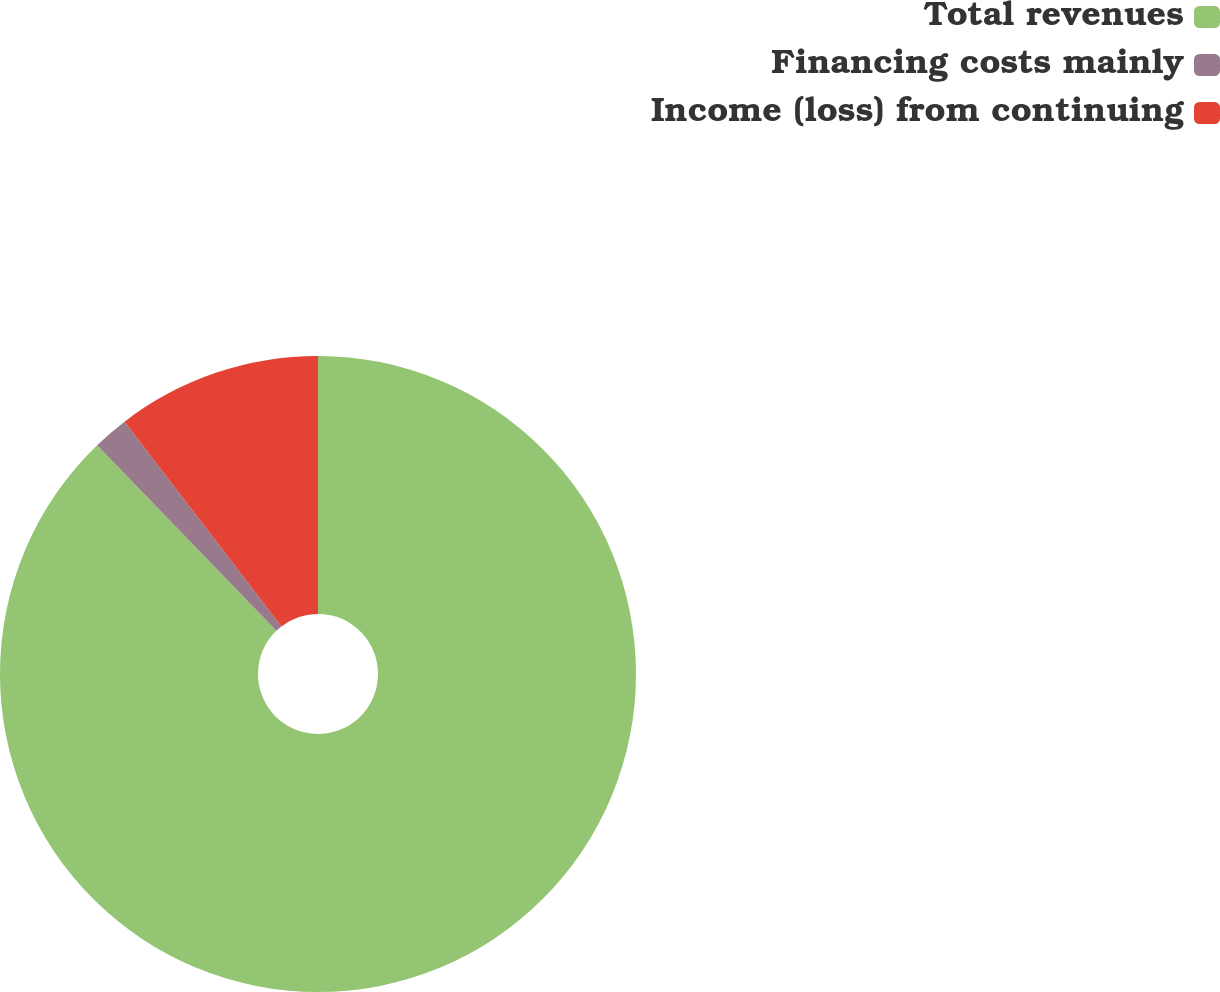Convert chart to OTSL. <chart><loc_0><loc_0><loc_500><loc_500><pie_chart><fcel>Total revenues<fcel>Financing costs mainly<fcel>Income (loss) from continuing<nl><fcel>87.78%<fcel>1.81%<fcel>10.41%<nl></chart> 